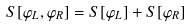<formula> <loc_0><loc_0><loc_500><loc_500>S [ \varphi _ { L } , \varphi _ { R } ] = S [ \varphi _ { L } ] + S [ \varphi _ { R } ]</formula> 